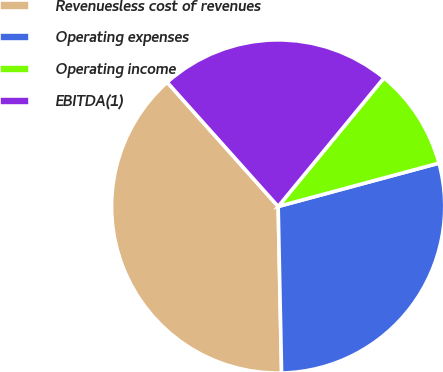Convert chart to OTSL. <chart><loc_0><loc_0><loc_500><loc_500><pie_chart><fcel>Revenuesless cost of revenues<fcel>Operating expenses<fcel>Operating income<fcel>EBITDA(1)<nl><fcel>38.72%<fcel>28.86%<fcel>9.85%<fcel>22.56%<nl></chart> 